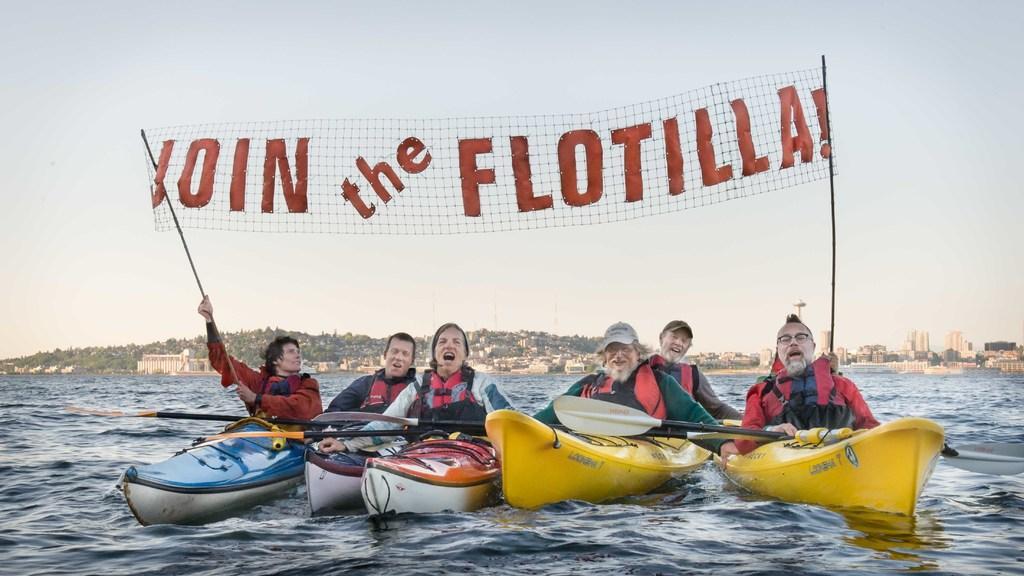Please provide a concise description of this image. In this picture I can see few people riding boats in the river. 